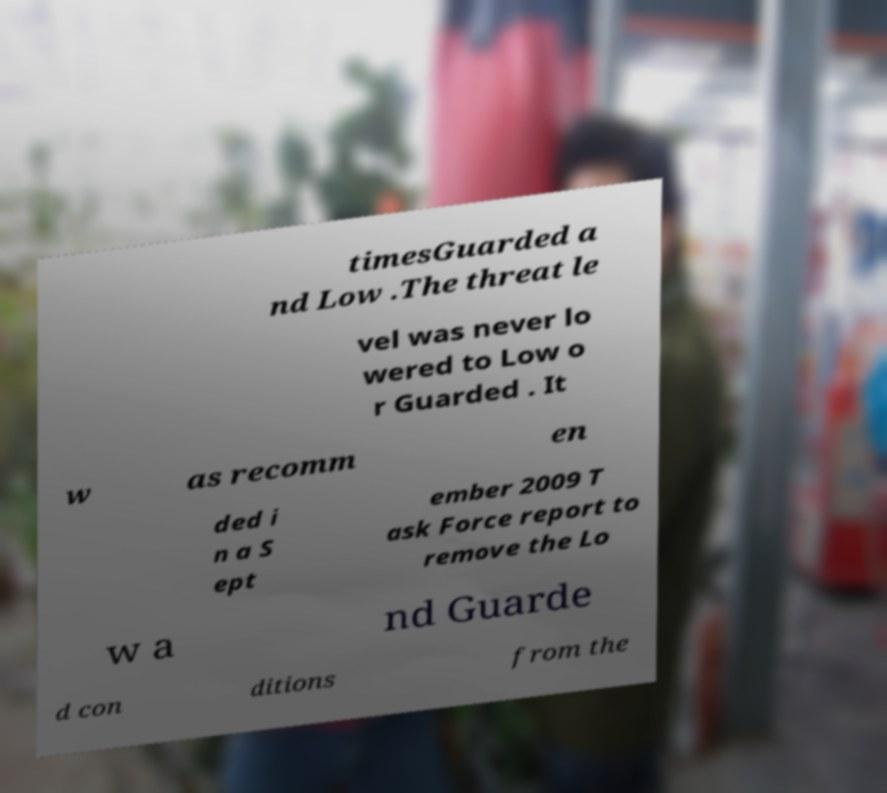Could you assist in decoding the text presented in this image and type it out clearly? timesGuarded a nd Low .The threat le vel was never lo wered to Low o r Guarded . It w as recomm en ded i n a S ept ember 2009 T ask Force report to remove the Lo w a nd Guarde d con ditions from the 